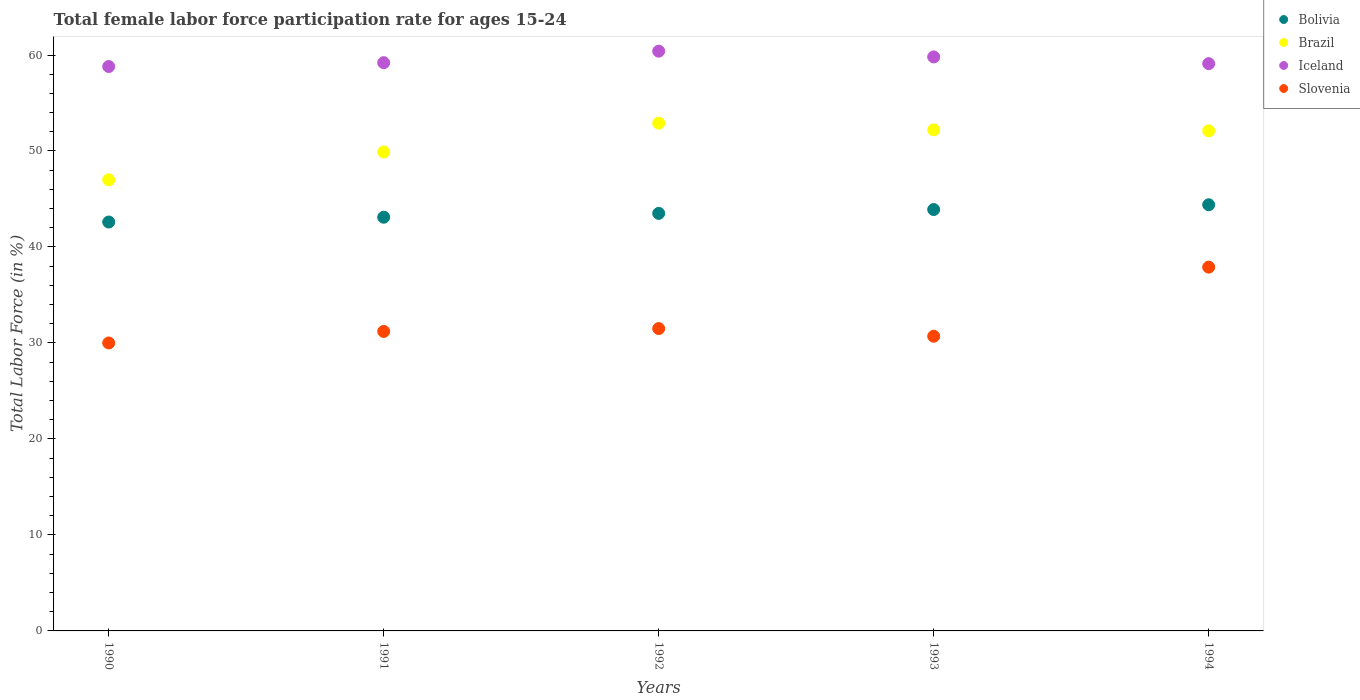Across all years, what is the maximum female labor force participation rate in Iceland?
Your response must be concise. 60.4. Across all years, what is the minimum female labor force participation rate in Brazil?
Your response must be concise. 47. In which year was the female labor force participation rate in Slovenia maximum?
Offer a very short reply. 1994. What is the total female labor force participation rate in Brazil in the graph?
Make the answer very short. 254.1. What is the difference between the female labor force participation rate in Brazil in 1993 and that in 1994?
Give a very brief answer. 0.1. What is the difference between the female labor force participation rate in Iceland in 1991 and the female labor force participation rate in Slovenia in 1994?
Keep it short and to the point. 21.3. What is the average female labor force participation rate in Iceland per year?
Provide a succinct answer. 59.46. In the year 1992, what is the difference between the female labor force participation rate in Bolivia and female labor force participation rate in Brazil?
Ensure brevity in your answer.  -9.4. What is the ratio of the female labor force participation rate in Iceland in 1990 to that in 1991?
Ensure brevity in your answer.  0.99. Is the female labor force participation rate in Iceland in 1993 less than that in 1994?
Offer a very short reply. No. Is the difference between the female labor force participation rate in Bolivia in 1990 and 1993 greater than the difference between the female labor force participation rate in Brazil in 1990 and 1993?
Your answer should be compact. Yes. What is the difference between the highest and the lowest female labor force participation rate in Iceland?
Provide a short and direct response. 1.6. In how many years, is the female labor force participation rate in Slovenia greater than the average female labor force participation rate in Slovenia taken over all years?
Ensure brevity in your answer.  1. Is it the case that in every year, the sum of the female labor force participation rate in Brazil and female labor force participation rate in Bolivia  is greater than the sum of female labor force participation rate in Slovenia and female labor force participation rate in Iceland?
Keep it short and to the point. No. Is it the case that in every year, the sum of the female labor force participation rate in Slovenia and female labor force participation rate in Iceland  is greater than the female labor force participation rate in Bolivia?
Make the answer very short. Yes. Does the female labor force participation rate in Iceland monotonically increase over the years?
Provide a short and direct response. No. What is the difference between two consecutive major ticks on the Y-axis?
Your answer should be compact. 10. Are the values on the major ticks of Y-axis written in scientific E-notation?
Make the answer very short. No. Does the graph contain grids?
Your answer should be compact. No. Where does the legend appear in the graph?
Provide a short and direct response. Top right. How are the legend labels stacked?
Keep it short and to the point. Vertical. What is the title of the graph?
Make the answer very short. Total female labor force participation rate for ages 15-24. What is the label or title of the Y-axis?
Ensure brevity in your answer.  Total Labor Force (in %). What is the Total Labor Force (in %) in Bolivia in 1990?
Ensure brevity in your answer.  42.6. What is the Total Labor Force (in %) in Iceland in 1990?
Give a very brief answer. 58.8. What is the Total Labor Force (in %) of Slovenia in 1990?
Make the answer very short. 30. What is the Total Labor Force (in %) of Bolivia in 1991?
Your answer should be compact. 43.1. What is the Total Labor Force (in %) in Brazil in 1991?
Provide a short and direct response. 49.9. What is the Total Labor Force (in %) in Iceland in 1991?
Your response must be concise. 59.2. What is the Total Labor Force (in %) in Slovenia in 1991?
Provide a short and direct response. 31.2. What is the Total Labor Force (in %) in Bolivia in 1992?
Offer a very short reply. 43.5. What is the Total Labor Force (in %) in Brazil in 1992?
Keep it short and to the point. 52.9. What is the Total Labor Force (in %) of Iceland in 1992?
Keep it short and to the point. 60.4. What is the Total Labor Force (in %) in Slovenia in 1992?
Your answer should be very brief. 31.5. What is the Total Labor Force (in %) in Bolivia in 1993?
Make the answer very short. 43.9. What is the Total Labor Force (in %) in Brazil in 1993?
Your answer should be compact. 52.2. What is the Total Labor Force (in %) of Iceland in 1993?
Your response must be concise. 59.8. What is the Total Labor Force (in %) in Slovenia in 1993?
Offer a terse response. 30.7. What is the Total Labor Force (in %) in Bolivia in 1994?
Give a very brief answer. 44.4. What is the Total Labor Force (in %) in Brazil in 1994?
Provide a short and direct response. 52.1. What is the Total Labor Force (in %) in Iceland in 1994?
Your response must be concise. 59.1. What is the Total Labor Force (in %) in Slovenia in 1994?
Provide a succinct answer. 37.9. Across all years, what is the maximum Total Labor Force (in %) in Bolivia?
Make the answer very short. 44.4. Across all years, what is the maximum Total Labor Force (in %) in Brazil?
Your answer should be very brief. 52.9. Across all years, what is the maximum Total Labor Force (in %) in Iceland?
Offer a very short reply. 60.4. Across all years, what is the maximum Total Labor Force (in %) in Slovenia?
Keep it short and to the point. 37.9. Across all years, what is the minimum Total Labor Force (in %) of Bolivia?
Offer a terse response. 42.6. Across all years, what is the minimum Total Labor Force (in %) of Iceland?
Make the answer very short. 58.8. What is the total Total Labor Force (in %) in Bolivia in the graph?
Provide a short and direct response. 217.5. What is the total Total Labor Force (in %) in Brazil in the graph?
Your response must be concise. 254.1. What is the total Total Labor Force (in %) of Iceland in the graph?
Provide a short and direct response. 297.3. What is the total Total Labor Force (in %) in Slovenia in the graph?
Give a very brief answer. 161.3. What is the difference between the Total Labor Force (in %) of Brazil in 1990 and that in 1991?
Provide a succinct answer. -2.9. What is the difference between the Total Labor Force (in %) in Bolivia in 1990 and that in 1992?
Offer a very short reply. -0.9. What is the difference between the Total Labor Force (in %) in Iceland in 1990 and that in 1992?
Your answer should be compact. -1.6. What is the difference between the Total Labor Force (in %) of Slovenia in 1990 and that in 1992?
Offer a terse response. -1.5. What is the difference between the Total Labor Force (in %) of Bolivia in 1991 and that in 1992?
Your answer should be compact. -0.4. What is the difference between the Total Labor Force (in %) of Iceland in 1991 and that in 1992?
Your answer should be compact. -1.2. What is the difference between the Total Labor Force (in %) of Slovenia in 1991 and that in 1992?
Provide a short and direct response. -0.3. What is the difference between the Total Labor Force (in %) in Slovenia in 1991 and that in 1993?
Give a very brief answer. 0.5. What is the difference between the Total Labor Force (in %) of Brazil in 1991 and that in 1994?
Provide a succinct answer. -2.2. What is the difference between the Total Labor Force (in %) in Iceland in 1991 and that in 1994?
Provide a succinct answer. 0.1. What is the difference between the Total Labor Force (in %) in Slovenia in 1991 and that in 1994?
Give a very brief answer. -6.7. What is the difference between the Total Labor Force (in %) of Slovenia in 1992 and that in 1993?
Your answer should be very brief. 0.8. What is the difference between the Total Labor Force (in %) in Bolivia in 1992 and that in 1994?
Make the answer very short. -0.9. What is the difference between the Total Labor Force (in %) in Iceland in 1992 and that in 1994?
Your answer should be very brief. 1.3. What is the difference between the Total Labor Force (in %) in Bolivia in 1993 and that in 1994?
Keep it short and to the point. -0.5. What is the difference between the Total Labor Force (in %) in Brazil in 1993 and that in 1994?
Offer a terse response. 0.1. What is the difference between the Total Labor Force (in %) of Iceland in 1993 and that in 1994?
Your response must be concise. 0.7. What is the difference between the Total Labor Force (in %) of Bolivia in 1990 and the Total Labor Force (in %) of Brazil in 1991?
Your answer should be very brief. -7.3. What is the difference between the Total Labor Force (in %) in Bolivia in 1990 and the Total Labor Force (in %) in Iceland in 1991?
Your answer should be compact. -16.6. What is the difference between the Total Labor Force (in %) in Brazil in 1990 and the Total Labor Force (in %) in Slovenia in 1991?
Your answer should be very brief. 15.8. What is the difference between the Total Labor Force (in %) in Iceland in 1990 and the Total Labor Force (in %) in Slovenia in 1991?
Make the answer very short. 27.6. What is the difference between the Total Labor Force (in %) of Bolivia in 1990 and the Total Labor Force (in %) of Brazil in 1992?
Offer a terse response. -10.3. What is the difference between the Total Labor Force (in %) in Bolivia in 1990 and the Total Labor Force (in %) in Iceland in 1992?
Your response must be concise. -17.8. What is the difference between the Total Labor Force (in %) in Iceland in 1990 and the Total Labor Force (in %) in Slovenia in 1992?
Your answer should be compact. 27.3. What is the difference between the Total Labor Force (in %) in Bolivia in 1990 and the Total Labor Force (in %) in Brazil in 1993?
Keep it short and to the point. -9.6. What is the difference between the Total Labor Force (in %) of Bolivia in 1990 and the Total Labor Force (in %) of Iceland in 1993?
Your answer should be compact. -17.2. What is the difference between the Total Labor Force (in %) of Bolivia in 1990 and the Total Labor Force (in %) of Slovenia in 1993?
Offer a very short reply. 11.9. What is the difference between the Total Labor Force (in %) of Brazil in 1990 and the Total Labor Force (in %) of Iceland in 1993?
Give a very brief answer. -12.8. What is the difference between the Total Labor Force (in %) of Iceland in 1990 and the Total Labor Force (in %) of Slovenia in 1993?
Your answer should be very brief. 28.1. What is the difference between the Total Labor Force (in %) of Bolivia in 1990 and the Total Labor Force (in %) of Iceland in 1994?
Your answer should be very brief. -16.5. What is the difference between the Total Labor Force (in %) of Brazil in 1990 and the Total Labor Force (in %) of Iceland in 1994?
Give a very brief answer. -12.1. What is the difference between the Total Labor Force (in %) of Iceland in 1990 and the Total Labor Force (in %) of Slovenia in 1994?
Provide a short and direct response. 20.9. What is the difference between the Total Labor Force (in %) of Bolivia in 1991 and the Total Labor Force (in %) of Iceland in 1992?
Offer a terse response. -17.3. What is the difference between the Total Labor Force (in %) of Brazil in 1991 and the Total Labor Force (in %) of Iceland in 1992?
Keep it short and to the point. -10.5. What is the difference between the Total Labor Force (in %) in Brazil in 1991 and the Total Labor Force (in %) in Slovenia in 1992?
Provide a succinct answer. 18.4. What is the difference between the Total Labor Force (in %) in Iceland in 1991 and the Total Labor Force (in %) in Slovenia in 1992?
Make the answer very short. 27.7. What is the difference between the Total Labor Force (in %) of Bolivia in 1991 and the Total Labor Force (in %) of Brazil in 1993?
Offer a terse response. -9.1. What is the difference between the Total Labor Force (in %) of Bolivia in 1991 and the Total Labor Force (in %) of Iceland in 1993?
Offer a very short reply. -16.7. What is the difference between the Total Labor Force (in %) of Bolivia in 1991 and the Total Labor Force (in %) of Slovenia in 1993?
Your answer should be compact. 12.4. What is the difference between the Total Labor Force (in %) of Brazil in 1991 and the Total Labor Force (in %) of Slovenia in 1993?
Give a very brief answer. 19.2. What is the difference between the Total Labor Force (in %) of Bolivia in 1991 and the Total Labor Force (in %) of Brazil in 1994?
Your answer should be very brief. -9. What is the difference between the Total Labor Force (in %) in Bolivia in 1991 and the Total Labor Force (in %) in Iceland in 1994?
Ensure brevity in your answer.  -16. What is the difference between the Total Labor Force (in %) in Brazil in 1991 and the Total Labor Force (in %) in Iceland in 1994?
Your response must be concise. -9.2. What is the difference between the Total Labor Force (in %) in Iceland in 1991 and the Total Labor Force (in %) in Slovenia in 1994?
Give a very brief answer. 21.3. What is the difference between the Total Labor Force (in %) in Bolivia in 1992 and the Total Labor Force (in %) in Iceland in 1993?
Your answer should be compact. -16.3. What is the difference between the Total Labor Force (in %) in Brazil in 1992 and the Total Labor Force (in %) in Slovenia in 1993?
Make the answer very short. 22.2. What is the difference between the Total Labor Force (in %) in Iceland in 1992 and the Total Labor Force (in %) in Slovenia in 1993?
Offer a terse response. 29.7. What is the difference between the Total Labor Force (in %) of Bolivia in 1992 and the Total Labor Force (in %) of Brazil in 1994?
Provide a succinct answer. -8.6. What is the difference between the Total Labor Force (in %) of Bolivia in 1992 and the Total Labor Force (in %) of Iceland in 1994?
Your response must be concise. -15.6. What is the difference between the Total Labor Force (in %) of Bolivia in 1992 and the Total Labor Force (in %) of Slovenia in 1994?
Ensure brevity in your answer.  5.6. What is the difference between the Total Labor Force (in %) of Brazil in 1992 and the Total Labor Force (in %) of Iceland in 1994?
Offer a very short reply. -6.2. What is the difference between the Total Labor Force (in %) of Brazil in 1992 and the Total Labor Force (in %) of Slovenia in 1994?
Your response must be concise. 15. What is the difference between the Total Labor Force (in %) in Bolivia in 1993 and the Total Labor Force (in %) in Brazil in 1994?
Your answer should be compact. -8.2. What is the difference between the Total Labor Force (in %) of Bolivia in 1993 and the Total Labor Force (in %) of Iceland in 1994?
Ensure brevity in your answer.  -15.2. What is the difference between the Total Labor Force (in %) in Bolivia in 1993 and the Total Labor Force (in %) in Slovenia in 1994?
Your answer should be very brief. 6. What is the difference between the Total Labor Force (in %) in Brazil in 1993 and the Total Labor Force (in %) in Iceland in 1994?
Keep it short and to the point. -6.9. What is the difference between the Total Labor Force (in %) in Iceland in 1993 and the Total Labor Force (in %) in Slovenia in 1994?
Provide a short and direct response. 21.9. What is the average Total Labor Force (in %) in Bolivia per year?
Offer a very short reply. 43.5. What is the average Total Labor Force (in %) in Brazil per year?
Offer a very short reply. 50.82. What is the average Total Labor Force (in %) of Iceland per year?
Make the answer very short. 59.46. What is the average Total Labor Force (in %) of Slovenia per year?
Provide a succinct answer. 32.26. In the year 1990, what is the difference between the Total Labor Force (in %) of Bolivia and Total Labor Force (in %) of Iceland?
Offer a terse response. -16.2. In the year 1990, what is the difference between the Total Labor Force (in %) in Iceland and Total Labor Force (in %) in Slovenia?
Keep it short and to the point. 28.8. In the year 1991, what is the difference between the Total Labor Force (in %) in Bolivia and Total Labor Force (in %) in Brazil?
Offer a very short reply. -6.8. In the year 1991, what is the difference between the Total Labor Force (in %) in Bolivia and Total Labor Force (in %) in Iceland?
Your response must be concise. -16.1. In the year 1991, what is the difference between the Total Labor Force (in %) in Brazil and Total Labor Force (in %) in Iceland?
Your answer should be compact. -9.3. In the year 1991, what is the difference between the Total Labor Force (in %) in Brazil and Total Labor Force (in %) in Slovenia?
Your response must be concise. 18.7. In the year 1991, what is the difference between the Total Labor Force (in %) of Iceland and Total Labor Force (in %) of Slovenia?
Provide a short and direct response. 28. In the year 1992, what is the difference between the Total Labor Force (in %) in Bolivia and Total Labor Force (in %) in Iceland?
Your answer should be compact. -16.9. In the year 1992, what is the difference between the Total Labor Force (in %) in Brazil and Total Labor Force (in %) in Slovenia?
Your answer should be very brief. 21.4. In the year 1992, what is the difference between the Total Labor Force (in %) of Iceland and Total Labor Force (in %) of Slovenia?
Your response must be concise. 28.9. In the year 1993, what is the difference between the Total Labor Force (in %) of Bolivia and Total Labor Force (in %) of Iceland?
Your response must be concise. -15.9. In the year 1993, what is the difference between the Total Labor Force (in %) in Brazil and Total Labor Force (in %) in Iceland?
Your response must be concise. -7.6. In the year 1993, what is the difference between the Total Labor Force (in %) of Iceland and Total Labor Force (in %) of Slovenia?
Offer a very short reply. 29.1. In the year 1994, what is the difference between the Total Labor Force (in %) of Bolivia and Total Labor Force (in %) of Brazil?
Offer a terse response. -7.7. In the year 1994, what is the difference between the Total Labor Force (in %) of Bolivia and Total Labor Force (in %) of Iceland?
Keep it short and to the point. -14.7. In the year 1994, what is the difference between the Total Labor Force (in %) in Brazil and Total Labor Force (in %) in Slovenia?
Offer a very short reply. 14.2. In the year 1994, what is the difference between the Total Labor Force (in %) in Iceland and Total Labor Force (in %) in Slovenia?
Provide a short and direct response. 21.2. What is the ratio of the Total Labor Force (in %) in Bolivia in 1990 to that in 1991?
Keep it short and to the point. 0.99. What is the ratio of the Total Labor Force (in %) in Brazil in 1990 to that in 1991?
Offer a very short reply. 0.94. What is the ratio of the Total Labor Force (in %) in Slovenia in 1990 to that in 1991?
Provide a short and direct response. 0.96. What is the ratio of the Total Labor Force (in %) of Bolivia in 1990 to that in 1992?
Provide a succinct answer. 0.98. What is the ratio of the Total Labor Force (in %) in Brazil in 1990 to that in 1992?
Offer a very short reply. 0.89. What is the ratio of the Total Labor Force (in %) of Iceland in 1990 to that in 1992?
Your answer should be compact. 0.97. What is the ratio of the Total Labor Force (in %) in Bolivia in 1990 to that in 1993?
Make the answer very short. 0.97. What is the ratio of the Total Labor Force (in %) of Brazil in 1990 to that in 1993?
Give a very brief answer. 0.9. What is the ratio of the Total Labor Force (in %) in Iceland in 1990 to that in 1993?
Your answer should be very brief. 0.98. What is the ratio of the Total Labor Force (in %) of Slovenia in 1990 to that in 1993?
Offer a terse response. 0.98. What is the ratio of the Total Labor Force (in %) of Bolivia in 1990 to that in 1994?
Your response must be concise. 0.96. What is the ratio of the Total Labor Force (in %) of Brazil in 1990 to that in 1994?
Your response must be concise. 0.9. What is the ratio of the Total Labor Force (in %) in Slovenia in 1990 to that in 1994?
Offer a very short reply. 0.79. What is the ratio of the Total Labor Force (in %) in Brazil in 1991 to that in 1992?
Provide a short and direct response. 0.94. What is the ratio of the Total Labor Force (in %) of Iceland in 1991 to that in 1992?
Make the answer very short. 0.98. What is the ratio of the Total Labor Force (in %) in Bolivia in 1991 to that in 1993?
Your answer should be compact. 0.98. What is the ratio of the Total Labor Force (in %) in Brazil in 1991 to that in 1993?
Keep it short and to the point. 0.96. What is the ratio of the Total Labor Force (in %) of Slovenia in 1991 to that in 1993?
Offer a terse response. 1.02. What is the ratio of the Total Labor Force (in %) in Bolivia in 1991 to that in 1994?
Offer a terse response. 0.97. What is the ratio of the Total Labor Force (in %) in Brazil in 1991 to that in 1994?
Keep it short and to the point. 0.96. What is the ratio of the Total Labor Force (in %) in Iceland in 1991 to that in 1994?
Provide a short and direct response. 1. What is the ratio of the Total Labor Force (in %) in Slovenia in 1991 to that in 1994?
Ensure brevity in your answer.  0.82. What is the ratio of the Total Labor Force (in %) in Bolivia in 1992 to that in 1993?
Give a very brief answer. 0.99. What is the ratio of the Total Labor Force (in %) in Brazil in 1992 to that in 1993?
Keep it short and to the point. 1.01. What is the ratio of the Total Labor Force (in %) of Slovenia in 1992 to that in 1993?
Give a very brief answer. 1.03. What is the ratio of the Total Labor Force (in %) in Bolivia in 1992 to that in 1994?
Provide a succinct answer. 0.98. What is the ratio of the Total Labor Force (in %) of Brazil in 1992 to that in 1994?
Give a very brief answer. 1.02. What is the ratio of the Total Labor Force (in %) in Iceland in 1992 to that in 1994?
Your answer should be very brief. 1.02. What is the ratio of the Total Labor Force (in %) of Slovenia in 1992 to that in 1994?
Your response must be concise. 0.83. What is the ratio of the Total Labor Force (in %) of Bolivia in 1993 to that in 1994?
Offer a terse response. 0.99. What is the ratio of the Total Labor Force (in %) in Iceland in 1993 to that in 1994?
Give a very brief answer. 1.01. What is the ratio of the Total Labor Force (in %) of Slovenia in 1993 to that in 1994?
Keep it short and to the point. 0.81. What is the difference between the highest and the second highest Total Labor Force (in %) of Brazil?
Your response must be concise. 0.7. What is the difference between the highest and the second highest Total Labor Force (in %) in Iceland?
Keep it short and to the point. 0.6. What is the difference between the highest and the second highest Total Labor Force (in %) in Slovenia?
Ensure brevity in your answer.  6.4. What is the difference between the highest and the lowest Total Labor Force (in %) in Bolivia?
Provide a short and direct response. 1.8. What is the difference between the highest and the lowest Total Labor Force (in %) in Iceland?
Give a very brief answer. 1.6. What is the difference between the highest and the lowest Total Labor Force (in %) of Slovenia?
Provide a short and direct response. 7.9. 